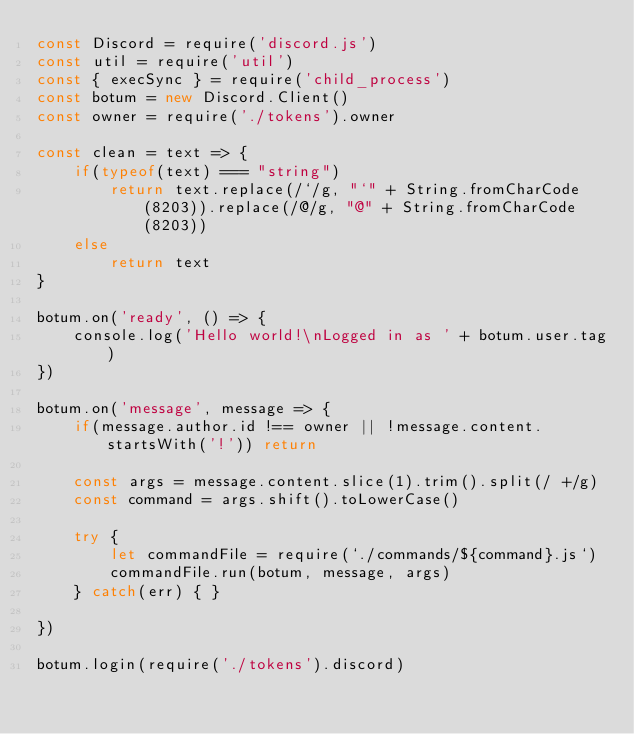Convert code to text. <code><loc_0><loc_0><loc_500><loc_500><_JavaScript_>const Discord = require('discord.js')
const util = require('util')
const { execSync } = require('child_process')
const botum = new Discord.Client()
const owner = require('./tokens').owner

const clean = text => {
    if(typeof(text) === "string")
        return text.replace(/`/g, "`" + String.fromCharCode(8203)).replace(/@/g, "@" + String.fromCharCode(8203))
    else
        return text
}

botum.on('ready', () => {
    console.log('Hello world!\nLogged in as ' + botum.user.tag)
})

botum.on('message', message => {
    if(message.author.id !== owner || !message.content.startsWith('!')) return
    
    const args = message.content.slice(1).trim().split(/ +/g)
    const command = args.shift().toLowerCase()

    try {
        let commandFile = require(`./commands/${command}.js`)
        commandFile.run(botum, message, args)
    } catch(err) { }

})

botum.login(require('./tokens').discord)</code> 